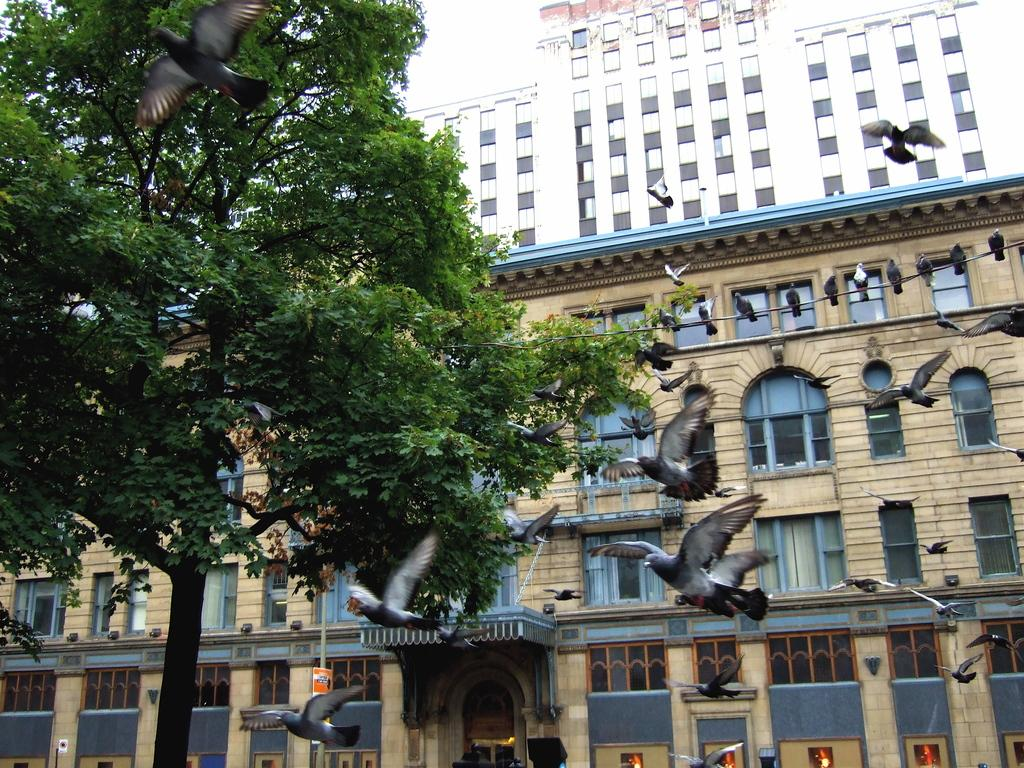What is happening in the sky in the image? There are birds flying in the air in the image. What type of vegetation is visible in the image? There is a tree visible in the image. What can be seen in the background of the image? There are buildings in the background. What is visible in the sky in the image? The sky is visible in the image. What type of fruit is hanging from the tree in the image? There is no fruit visible on the tree in the image. Can you tell me how many sinks are present in the image? There are no sinks present in the image. 